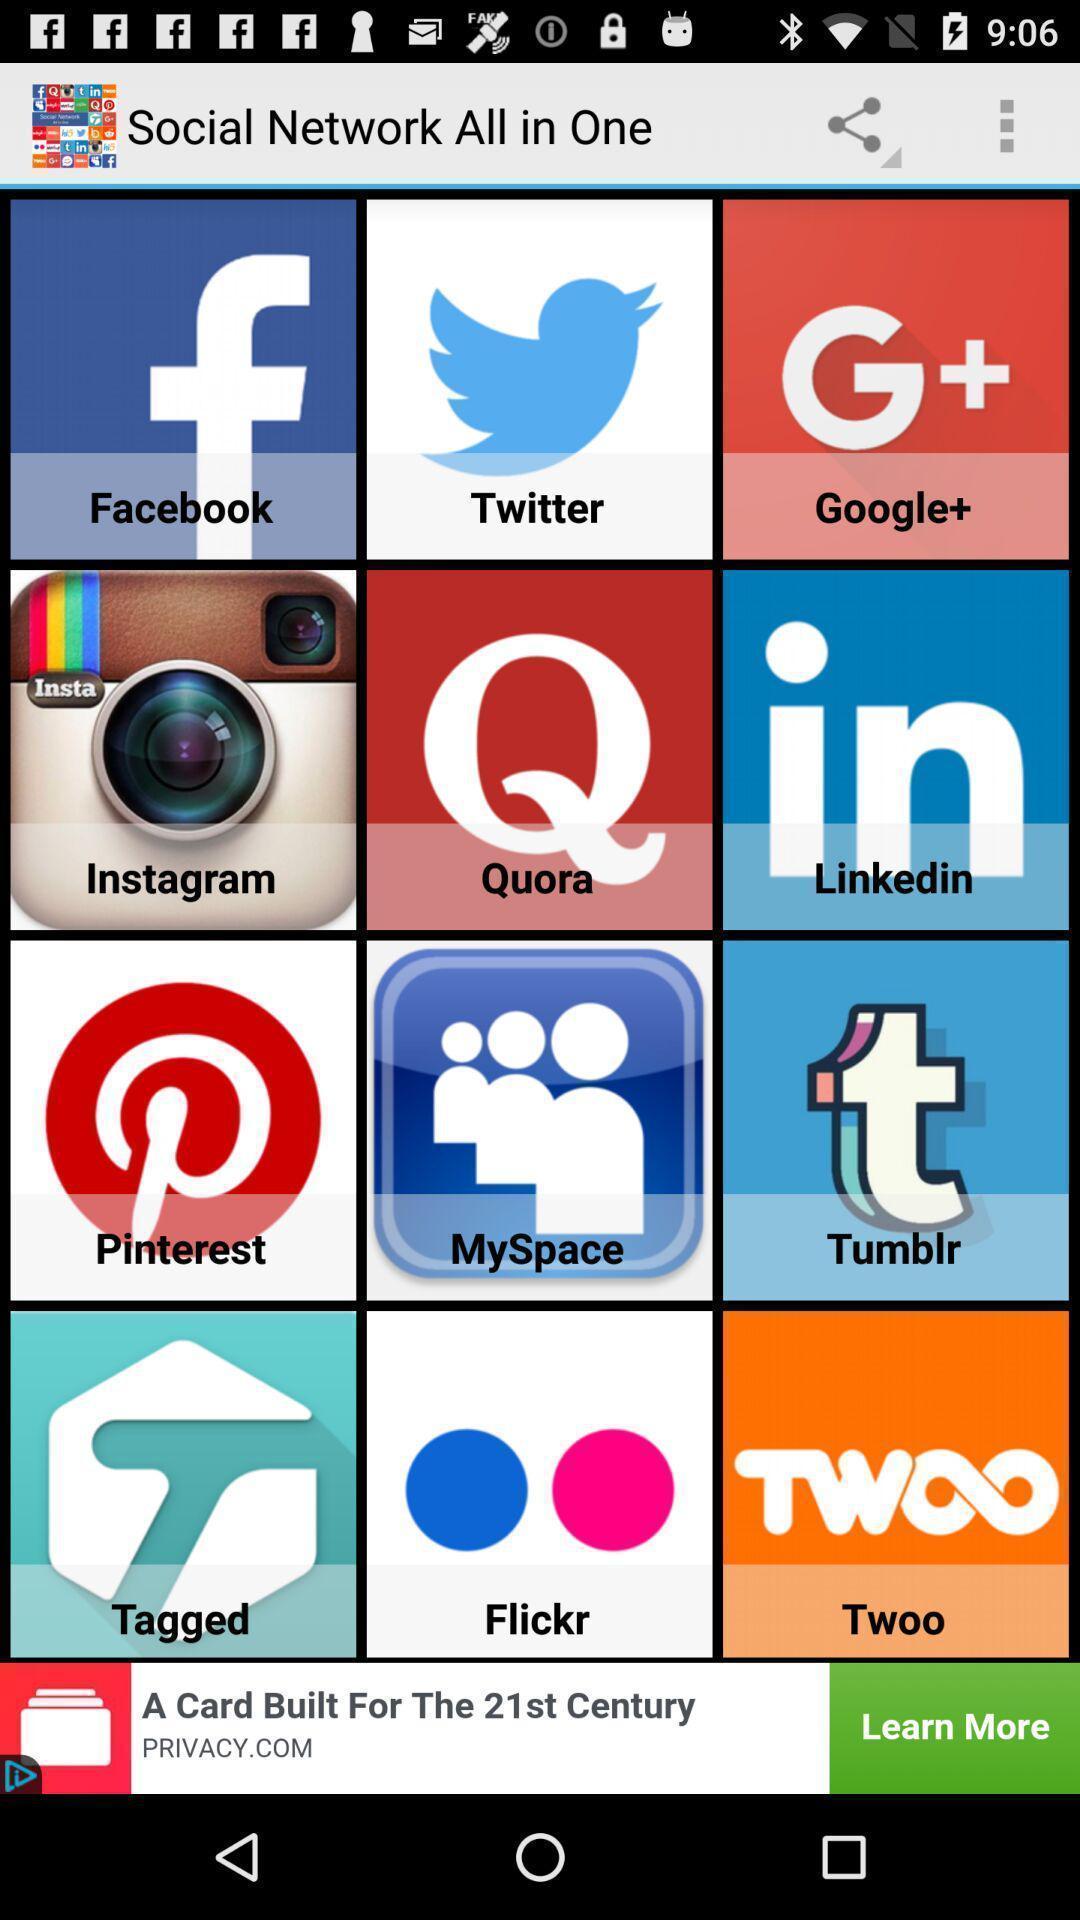Tell me what you see in this picture. Page showing different social apps. 